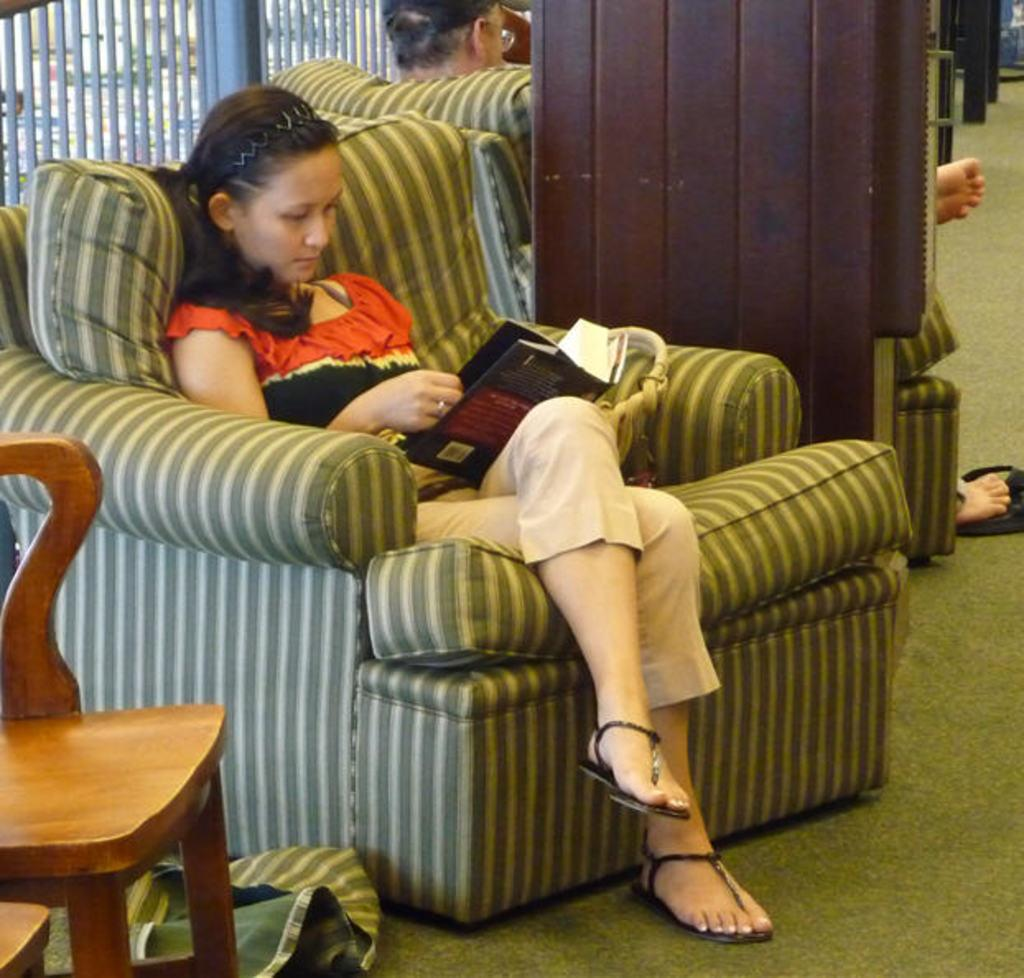What is the main subject of the image? The main subject of the image is a woman. What is the woman doing in the image? The woman is sitting in a sofa and reading a book. What type of vegetable is the woman holding in the image? There is no vegetable present in the image; the woman is reading a book. How does the woman maintain a quiet environment while reading in the image? The image does not provide information about the noise level or the woman's actions to maintain a quiet environment. 